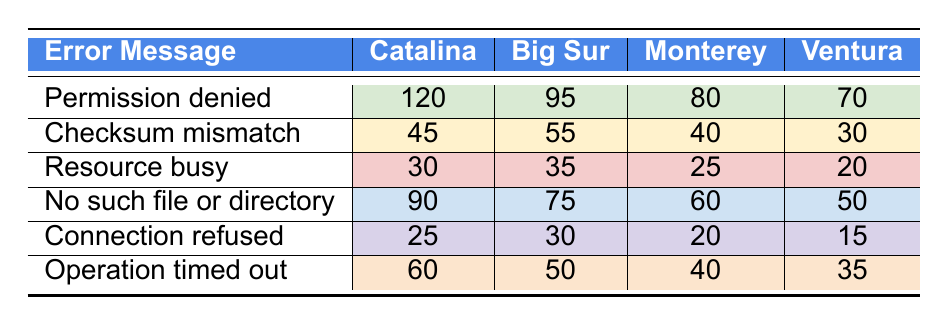What is the error message with the highest occurrence in Catalina? In the Catalina column, the highest occurrence is 120 for the error message "Permission denied."
Answer: Permission denied Which error message had the lowest frequency in Ventura? The error message with the lowest frequency in Ventura is "Connection refused" with 15 occurrences.
Answer: Connection refused How many more occurrences of "Operation timed out" are there in Catalina compared to Monterey? In Catalina, "Operation timed out" has 60 occurrences while in Monterey it has 40 occurrences. The difference is 60 - 40 = 20.
Answer: 20 What is the total number of occurrences for the error message "Resource busy" across all macOS versions? The occurrences of "Resource busy" are 30 (Catalina) + 35 (Big Sur) + 25 (Monterey) + 20 (Ventura) = 110.
Answer: 110 Is the occurrence of "Checksum mismatch" higher in Big Sur than in Monterey? In Big Sur, "Checksum mismatch" has 55 occurrences, while in Monterey it has 40 occurrences. Therefore, it is higher in Big Sur.
Answer: Yes What error message has the highest decrease in occurrences from Catalina to Ventura? For "Permission denied," it decreases from 120 to 70 (50 decrease), and for "No such file or directory," it decreases from 90 to 50 (40 decrease). "Permission denied" has the highest decrease of 50.
Answer: Permission denied What is the average occurrence of "Connection refused" across all macOS versions? The occurrences for "Connection refused" are 25 (Catalina) + 30 (Big Sur) + 20 (Monterey) + 15 (Ventura) = 90. The average is 90 divided by 4 = 22.5.
Answer: 22.5 Which macOS version has the highest total number of error occurrences? Summing the occurrences for each version: Catalina (120+45+30+90+25+60 = 370), Big Sur (95+55+35+75+30+50 = 340), Monterey (80+40+25+60+20+40 = 265), Ventura (70+30+20+50+15+35 = 220). Catalina has the highest total of 370.
Answer: Catalina 